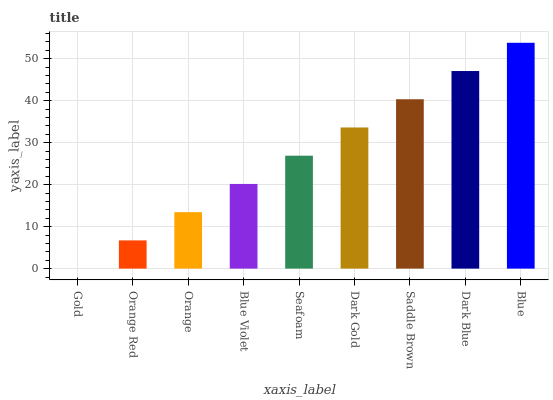Is Gold the minimum?
Answer yes or no. Yes. Is Blue the maximum?
Answer yes or no. Yes. Is Orange Red the minimum?
Answer yes or no. No. Is Orange Red the maximum?
Answer yes or no. No. Is Orange Red greater than Gold?
Answer yes or no. Yes. Is Gold less than Orange Red?
Answer yes or no. Yes. Is Gold greater than Orange Red?
Answer yes or no. No. Is Orange Red less than Gold?
Answer yes or no. No. Is Seafoam the high median?
Answer yes or no. Yes. Is Seafoam the low median?
Answer yes or no. Yes. Is Orange the high median?
Answer yes or no. No. Is Orange the low median?
Answer yes or no. No. 